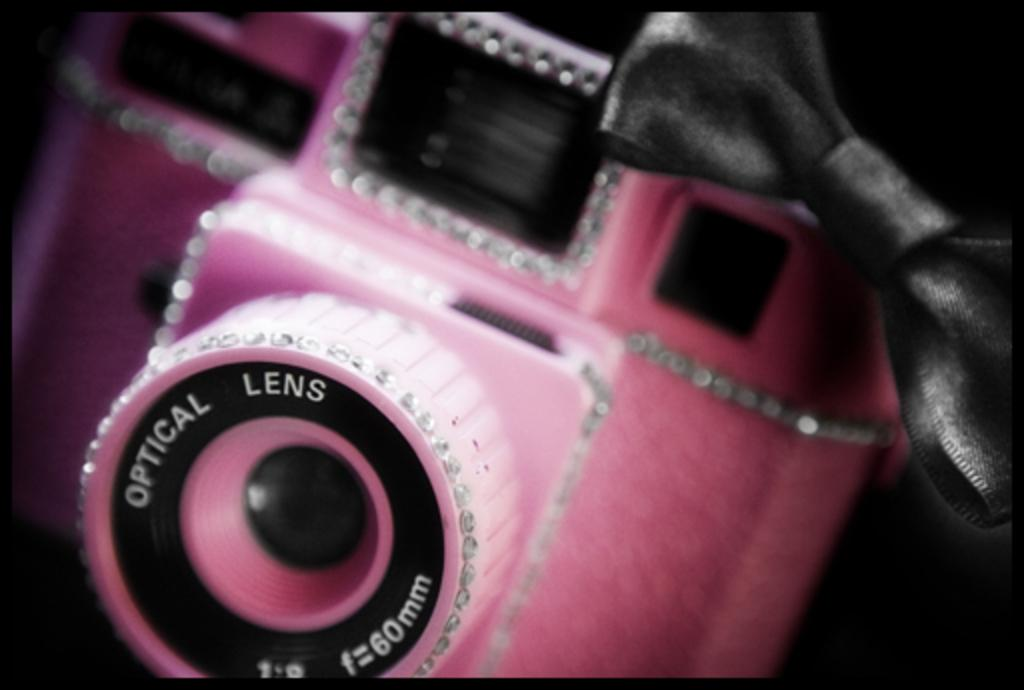What is the color of the camera in the image? The camera in the image is pink. What is the camera's purpose in the image? The camera is the main subject of the image, but its purpose is not explicitly stated. What is hanging above the camera in the image? There is a ribbon above the camera in the image. What type of texture can be seen on the camera in the image? The provided facts do not mention any specific texture on the camera, so we cannot answer this question definitively. 